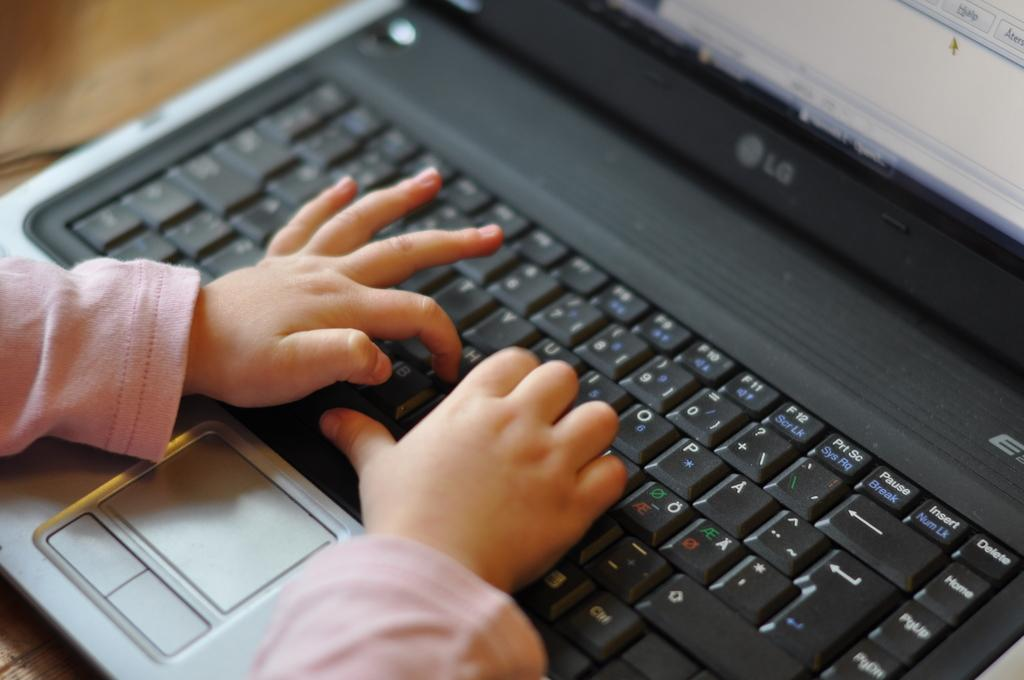<image>
Summarize the visual content of the image. The child is typing on the keyboard of an LG laptop. 